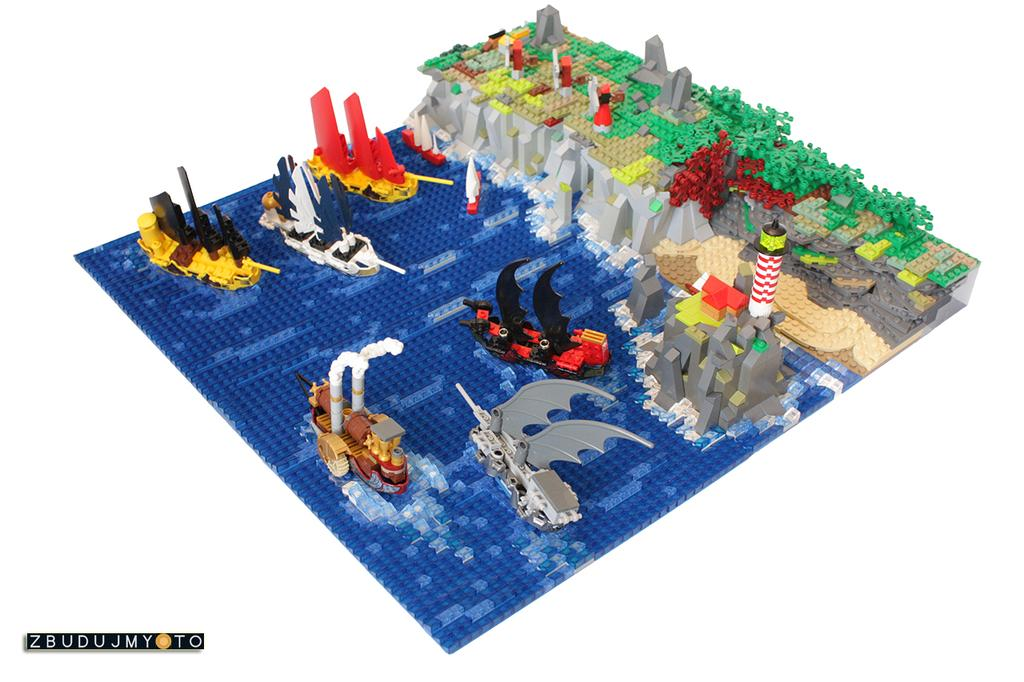What is the main subject of the image? The main subject of the image is an object made with Lego. What can be seen on the Lego object? There are toys on the Lego object. What type of discussion is taking place between the toys on the Lego object? There is no discussion taking place between the toys on the Lego object, as they are inanimate objects and cannot engage in conversation. 